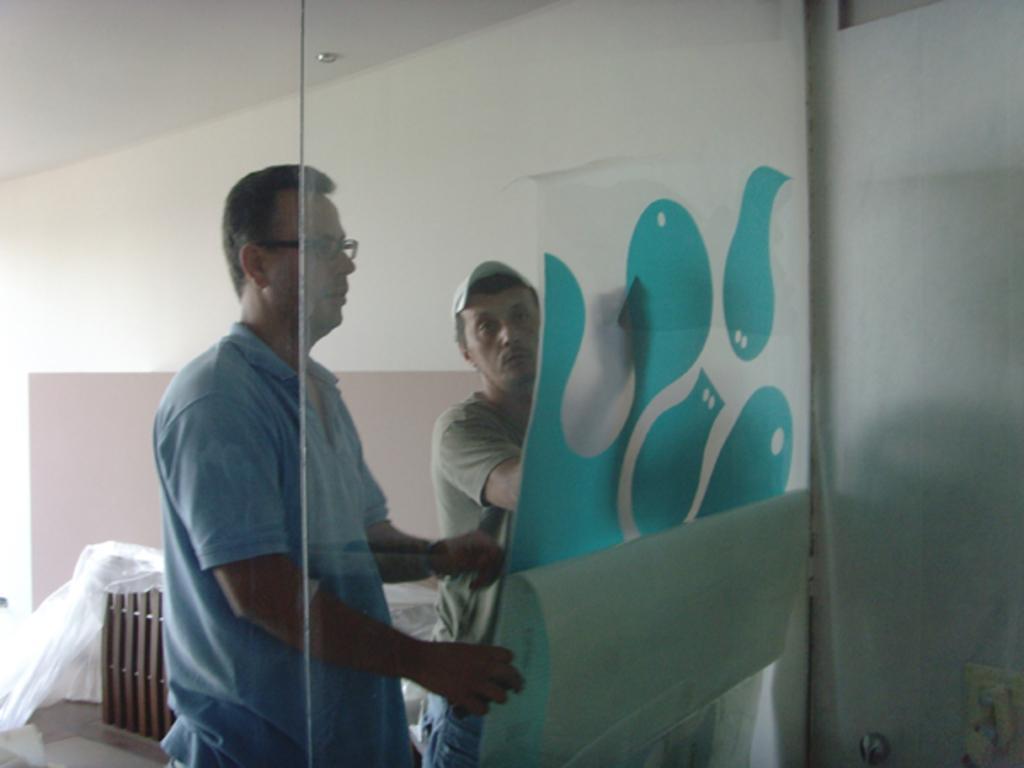Please provide a concise description of this image. This picture is clicked inside. In the center we can see the two persons wearing t-shirts, holding some object. In the background there is a wall, roof and some wooden object. 